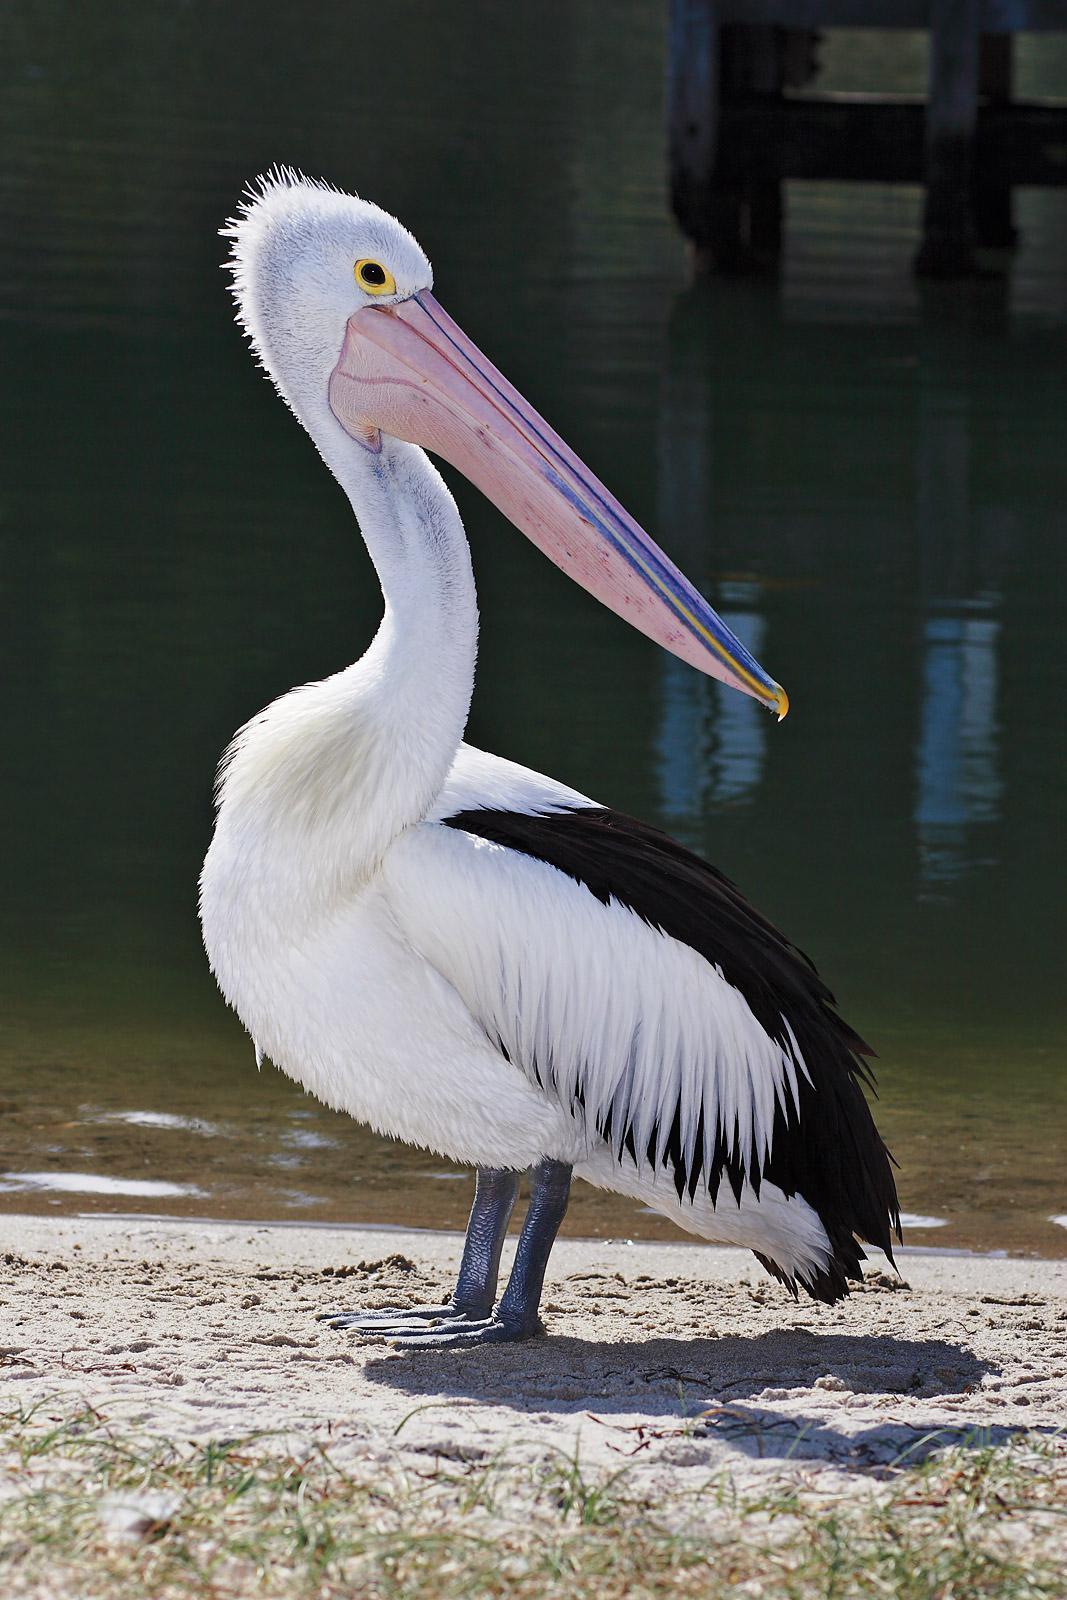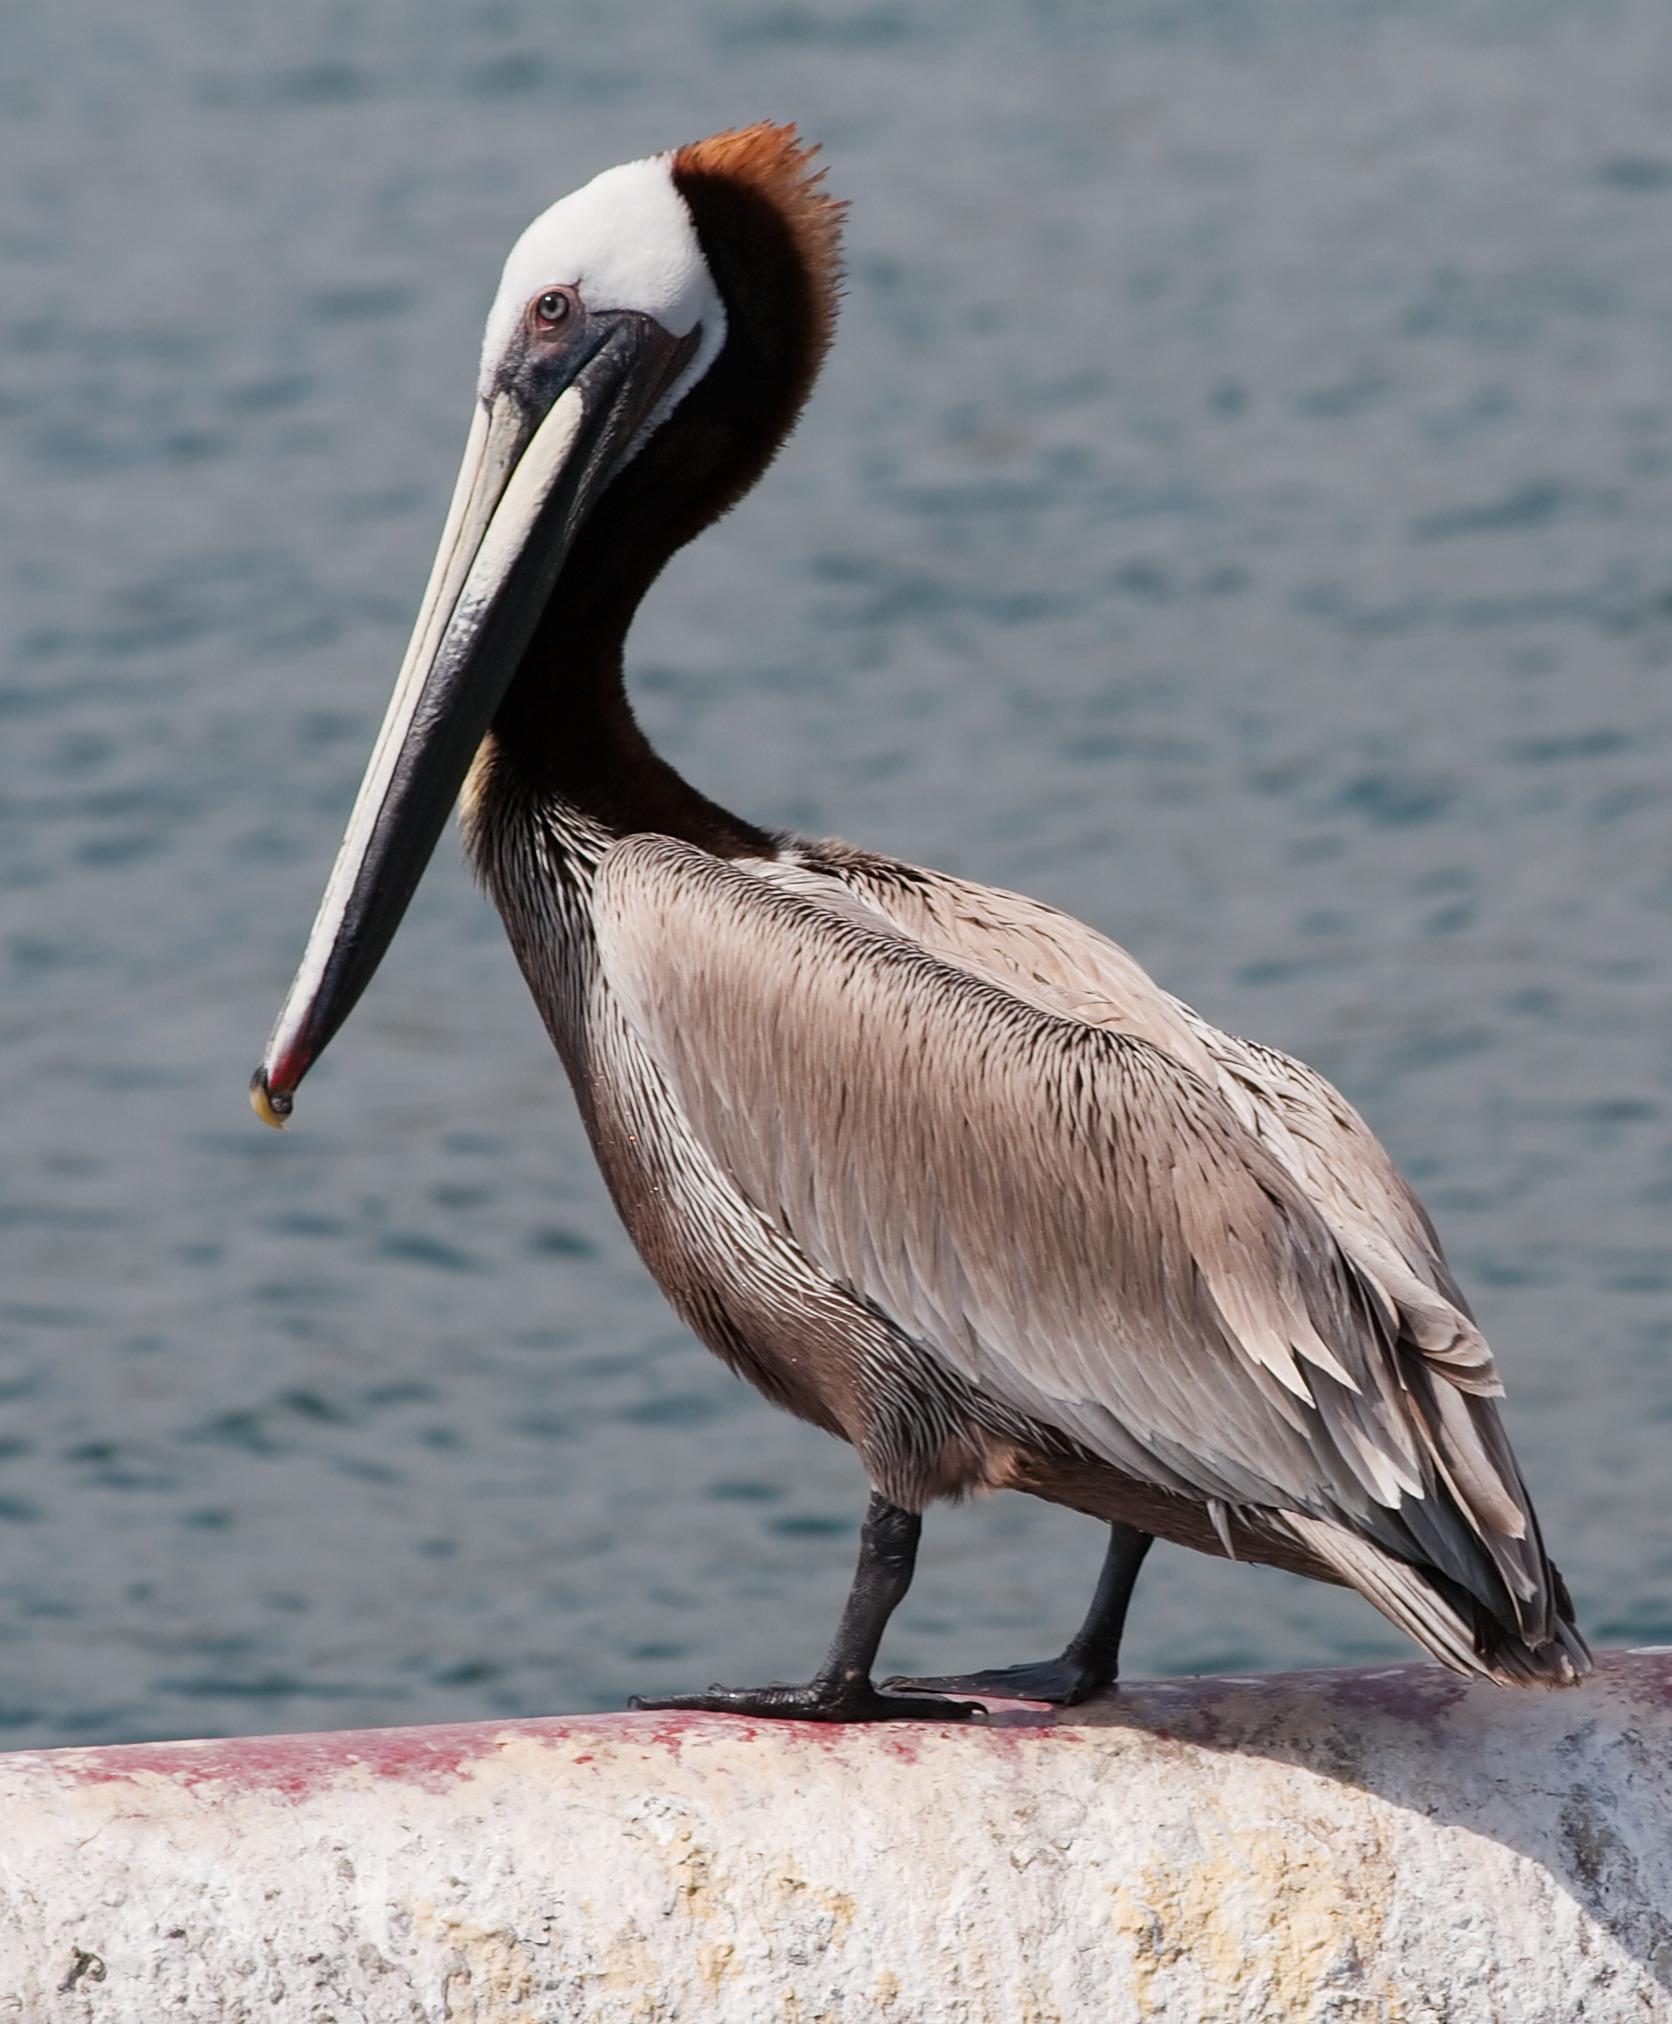The first image is the image on the left, the second image is the image on the right. Given the left and right images, does the statement "At least one bird is sitting on water." hold true? Answer yes or no. No. 